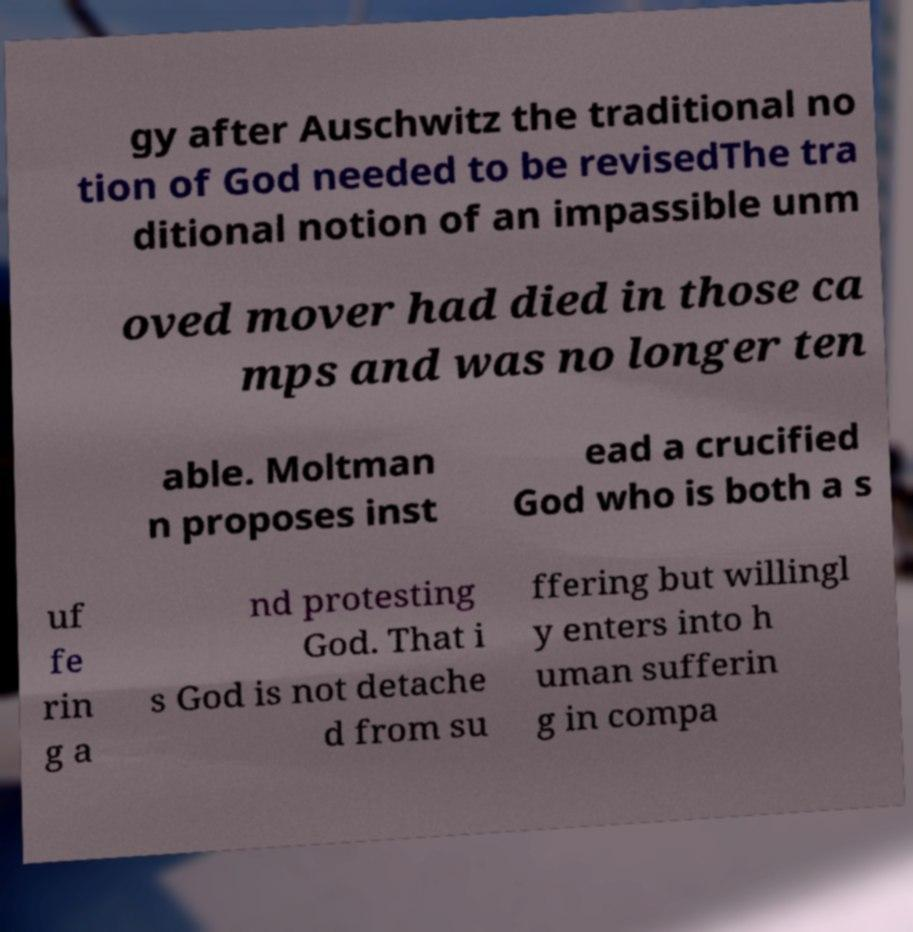Please identify and transcribe the text found in this image. gy after Auschwitz the traditional no tion of God needed to be revisedThe tra ditional notion of an impassible unm oved mover had died in those ca mps and was no longer ten able. Moltman n proposes inst ead a crucified God who is both a s uf fe rin g a nd protesting God. That i s God is not detache d from su ffering but willingl y enters into h uman sufferin g in compa 